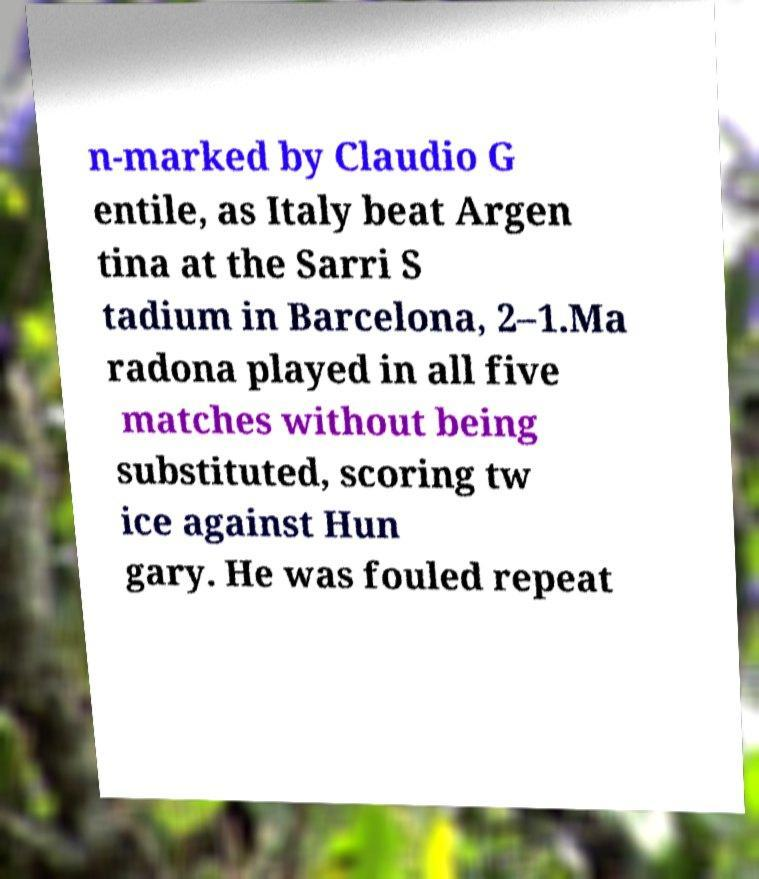Could you assist in decoding the text presented in this image and type it out clearly? n-marked by Claudio G entile, as Italy beat Argen tina at the Sarri S tadium in Barcelona, 2–1.Ma radona played in all five matches without being substituted, scoring tw ice against Hun gary. He was fouled repeat 